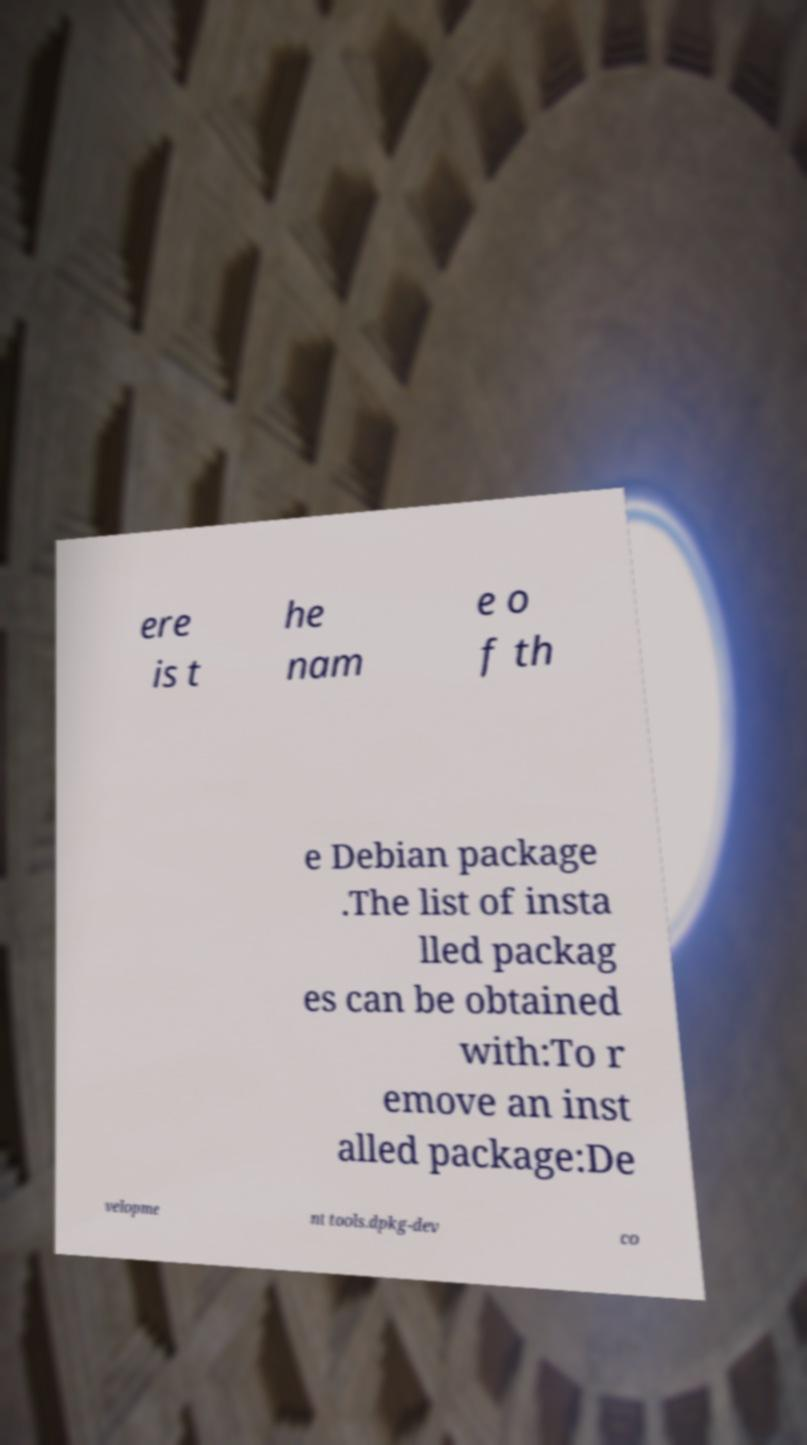For documentation purposes, I need the text within this image transcribed. Could you provide that? ere is t he nam e o f th e Debian package .The list of insta lled packag es can be obtained with:To r emove an inst alled package:De velopme nt tools.dpkg-dev co 